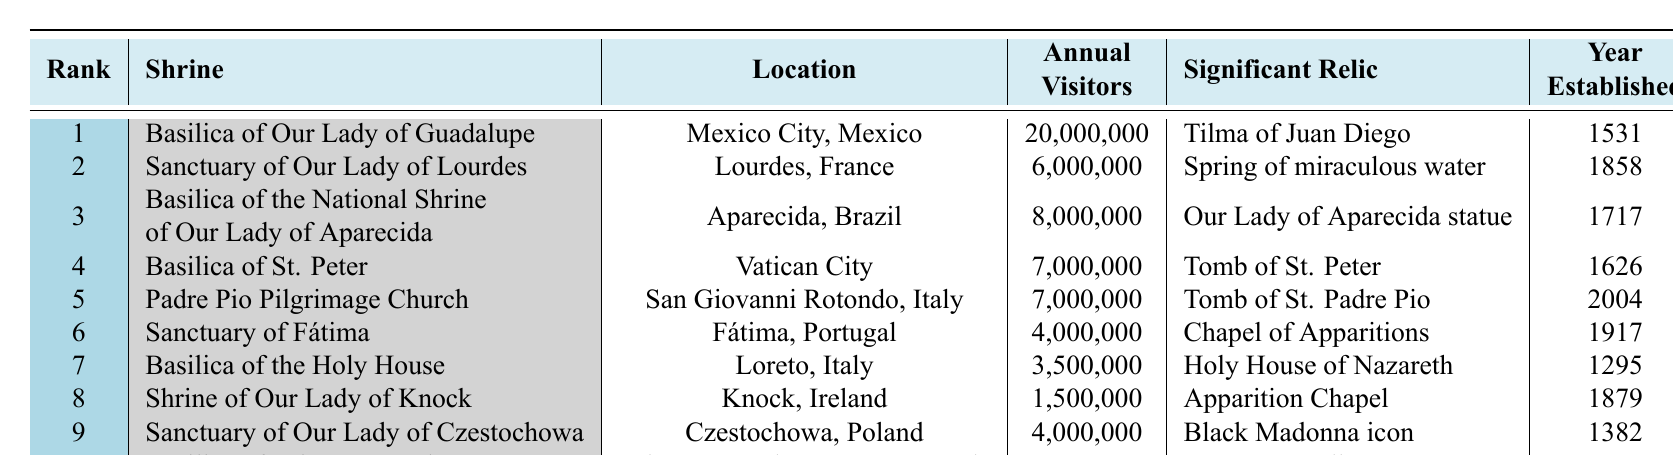What is the location of the Sanctuary of Our Lady of Lourdes? The table lists the location of each shrine. According to the entry for the Sanctuary of Our Lady of Lourdes, it is located in Lourdes, France.
Answer: Lourdes, France Which shrine has the highest annual visitors? To find the shrine with the highest annual visitors, we look for the highest number in the "Annual Visitors" column. The Basilica of Our Lady of Guadalupe has 20,000,000 visitors, which is the highest.
Answer: Basilica of Our Lady of Guadalupe What relic is associated with the Basilica of St. Peter? The table specifies the significant relic for each shrine. According to the entry for the Basilica of St. Peter, the relic is the Tomb of St. Peter.
Answer: Tomb of St. Peter How many more visitors does the Basilica of the National Shrine of Our Lady of Aparecida have compared to the Sanctuary of Fátima? We find the annual visitors for each shrine: the Basilica of the National Shrine of Our Lady of Aparecida has 8,000,000 visitors, and the Sanctuary of Fátima has 4,000,000. The difference is 8,000,000 - 4,000,000 = 4,000,000.
Answer: 4,000,000 Is it true that the Basilica of Sainte-Anne-de-Beaupré has more annual visitors than the Shrine of Our Lady of Knock? We compare the annual visitors: the Basilica of Sainte-Anne-de-Beaupré has 1,000,000, and the Shrine of Our Lady of Knock has 1,500,000. Since 1,000,000 is less than 1,500,000, the statement is false.
Answer: False What is the average number of annual visitors for the top three shrines listed? The top three shrines' annual visitors are: Basilica of Our Lady of Guadalupe (20,000,000), Basilica of the National Shrine of Our Lady of Aparecida (8,000,000), and Basilica of St. Peter (7,000,000). We sum these: 20,000,000 + 8,000,000 + 7,000,000 = 35,000,000. Then, we divide by 3 to find the average: 35,000,000 / 3 = 11,666,667.
Answer: 11,666,667 Which shrine is established the earliest and what is its year of establishment? We check the "Year Established" column for all shrines. The earliest year is 1295 for the Basilica of the Holy House.
Answer: Basilica of the Holy House, 1295 How many shrines have annual visitors over 5 million? We review the annual visitors counts: Basilica of Our Lady of Guadalupe (20,000,000), Sanctuary of Our Lady of Lourdes (6,000,000), Basilica of the National Shrine of Our Lady of Aparecida (8,000,000), Basilica of St. Peter (7,000,000), and Padre Pio Pilgrimage Church (7,000,000). This gives a total of 5 shrines with more than 5 million visitors.
Answer: 5 Which country has the most shrines in the top 10 list? We analyze the "Location" column to count the occurrences per country. Mexico (1), France (1), Brazil (1), Vatican City (1), Italy (2), Portugal (1), Ireland (1), Poland (1), Canada (1). Italy has the most with 2 shrines.
Answer: Italy 